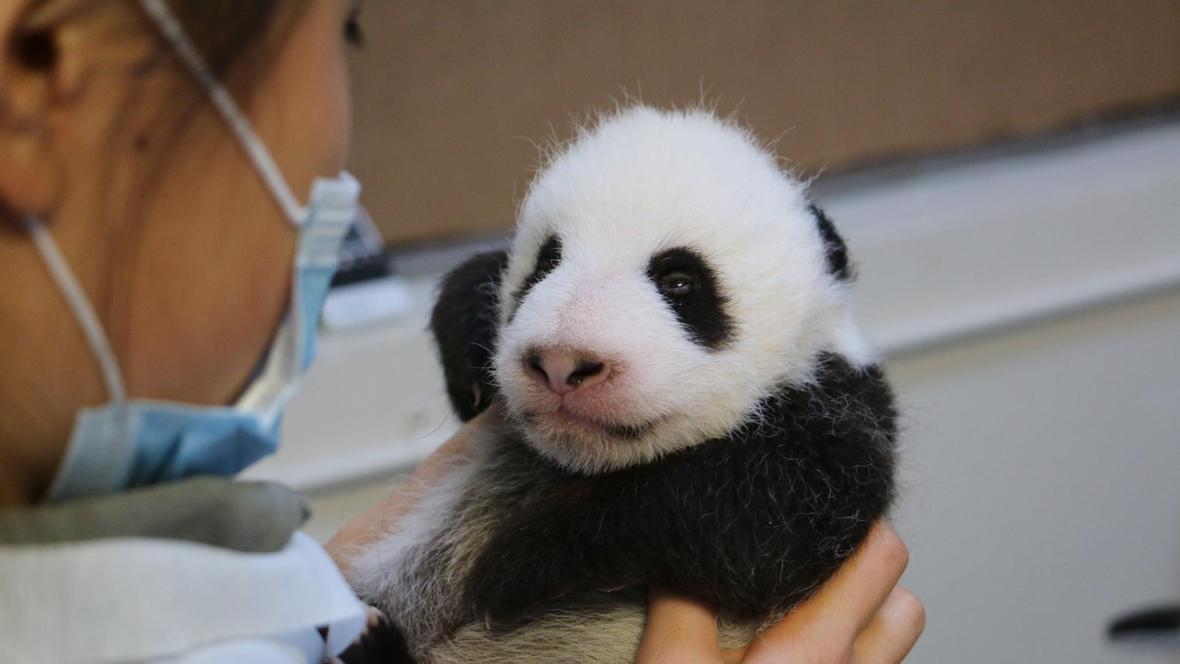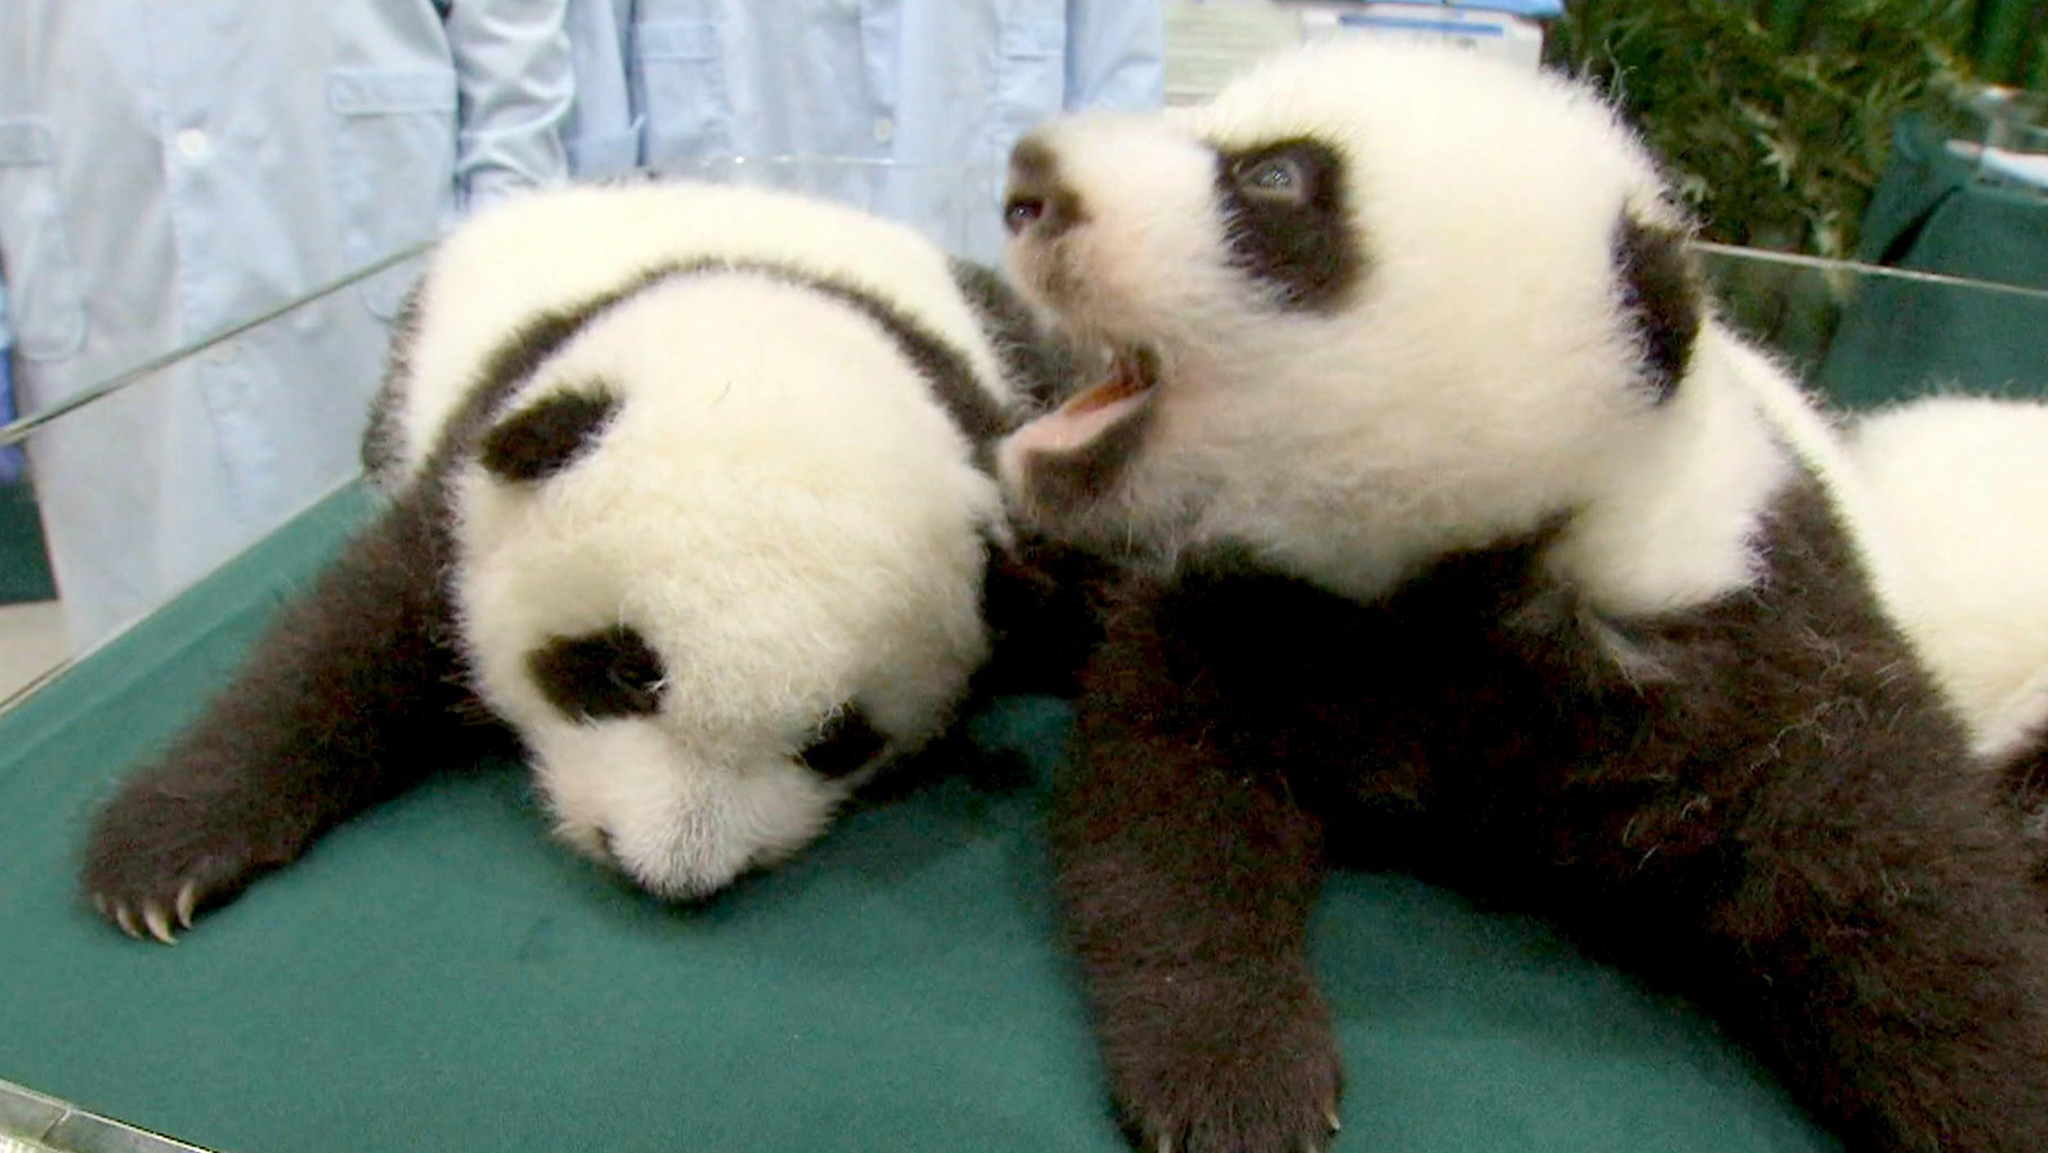The first image is the image on the left, the second image is the image on the right. Given the left and right images, does the statement "One image contains twice as many pandas as the other image, and one panda has an open mouth and wide-open eyes." hold true? Answer yes or no. Yes. The first image is the image on the left, the second image is the image on the right. Analyze the images presented: Is the assertion "In one image, a small panda is being held at an indoor location by a person who is wearing a medical protective item." valid? Answer yes or no. Yes. 